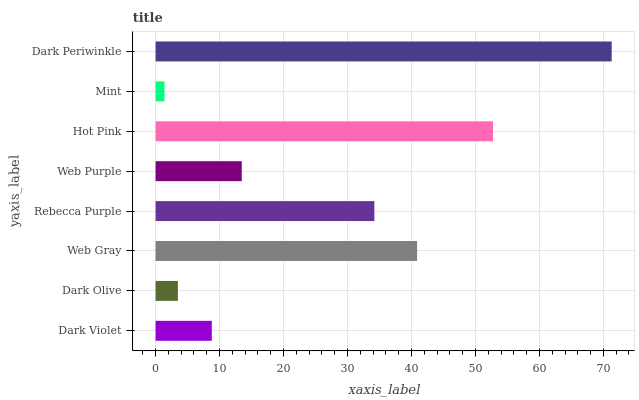Is Mint the minimum?
Answer yes or no. Yes. Is Dark Periwinkle the maximum?
Answer yes or no. Yes. Is Dark Olive the minimum?
Answer yes or no. No. Is Dark Olive the maximum?
Answer yes or no. No. Is Dark Violet greater than Dark Olive?
Answer yes or no. Yes. Is Dark Olive less than Dark Violet?
Answer yes or no. Yes. Is Dark Olive greater than Dark Violet?
Answer yes or no. No. Is Dark Violet less than Dark Olive?
Answer yes or no. No. Is Rebecca Purple the high median?
Answer yes or no. Yes. Is Web Purple the low median?
Answer yes or no. Yes. Is Dark Periwinkle the high median?
Answer yes or no. No. Is Dark Olive the low median?
Answer yes or no. No. 